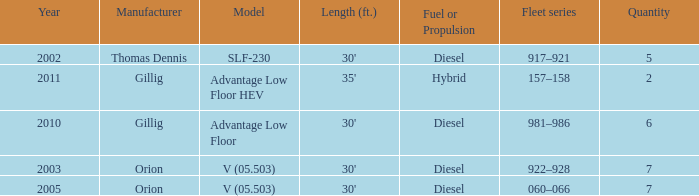Specify the series of fleets with a count of 917–921. 